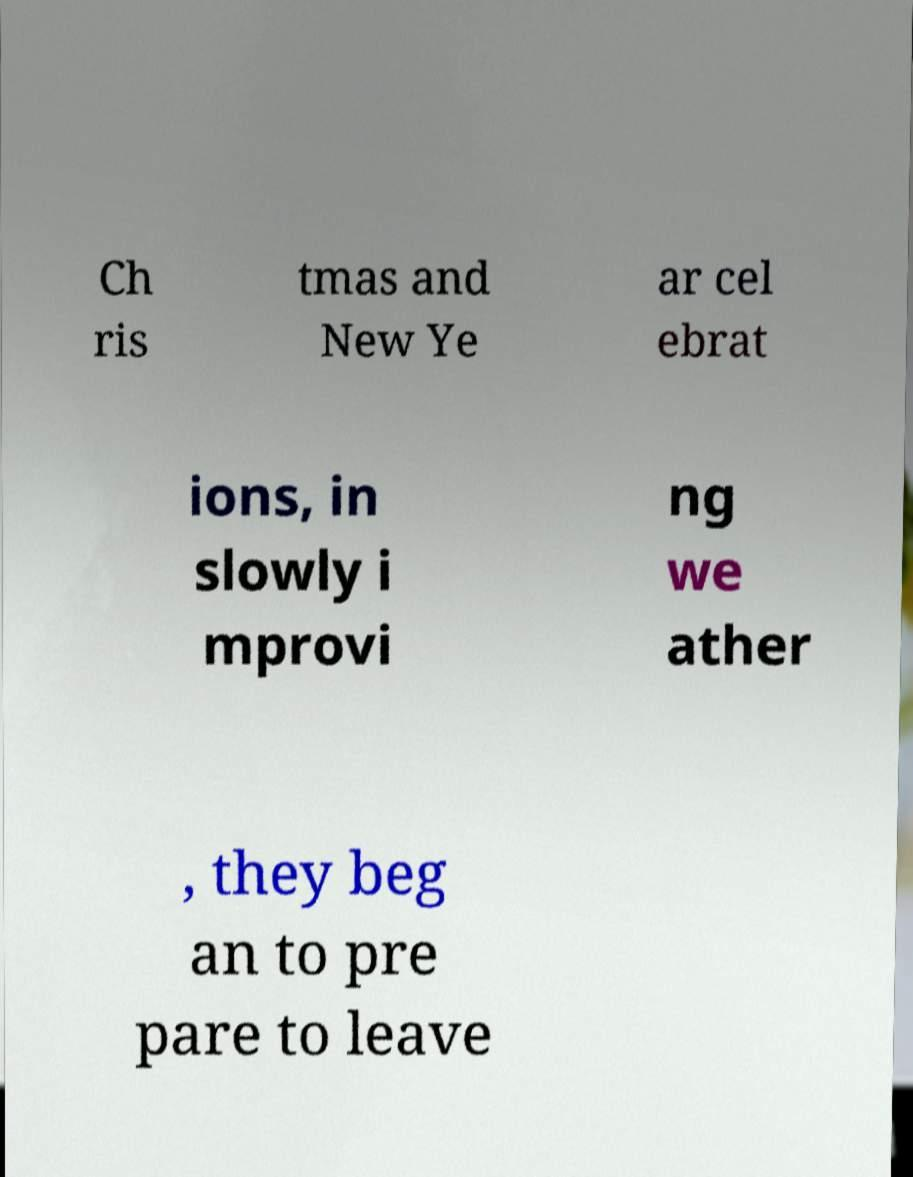Please identify and transcribe the text found in this image. Ch ris tmas and New Ye ar cel ebrat ions, in slowly i mprovi ng we ather , they beg an to pre pare to leave 